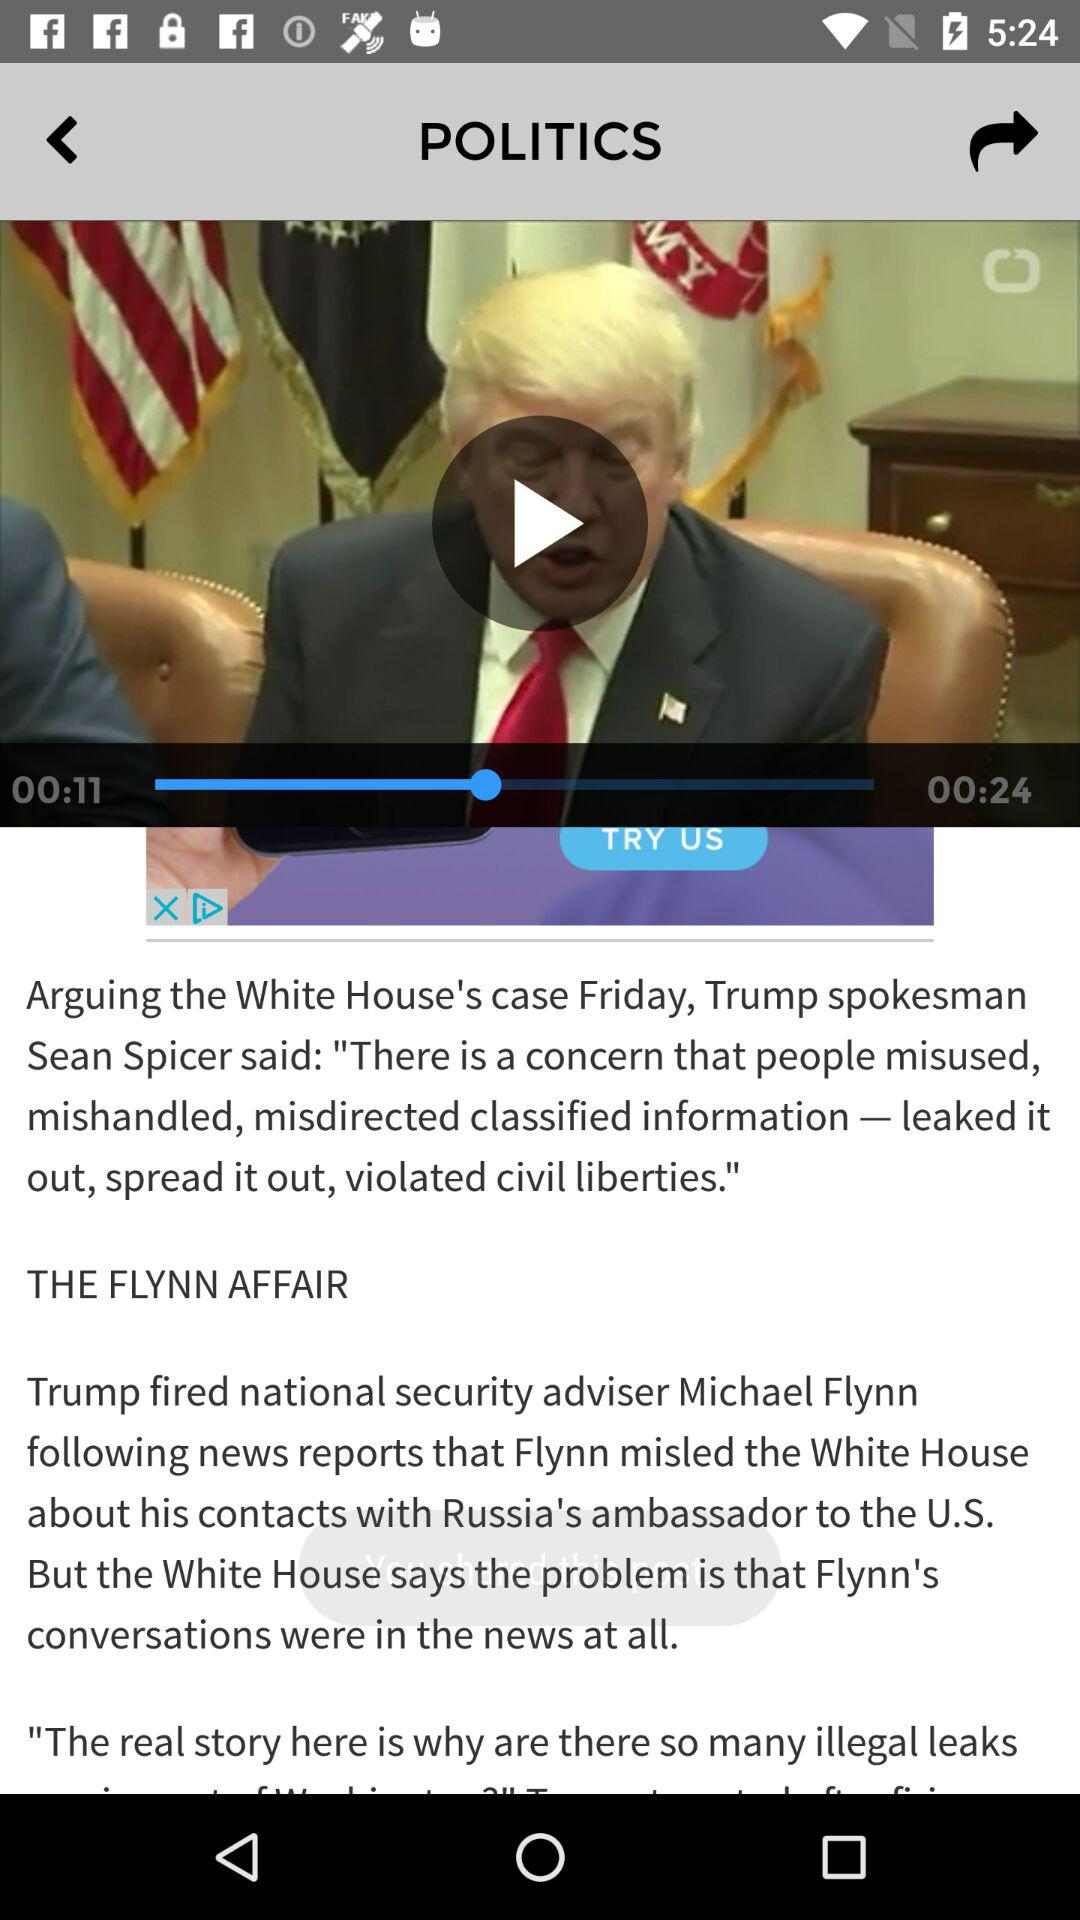How many more seconds is the video length than the time elapsed?
Answer the question using a single word or phrase. 13 